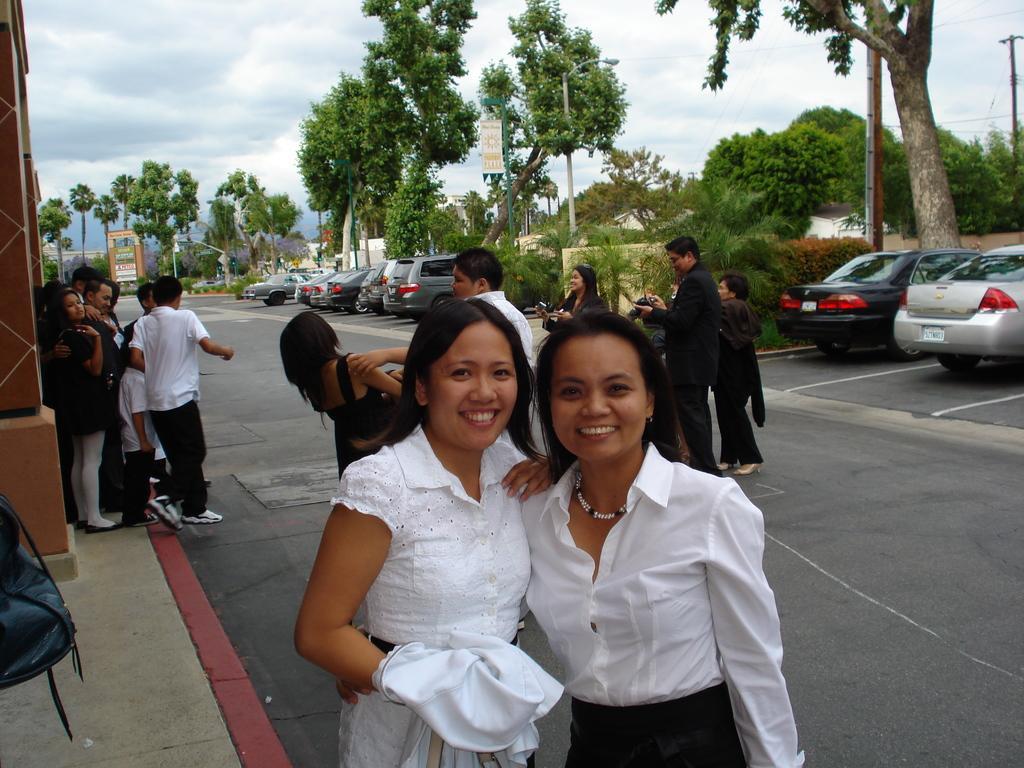Describe this image in one or two sentences. In this image we can see men and women are standing on the road and pavement. In the background, we can see cars, trees, plants, boards, poles and wires. At the top of the image, we can see the sky with clouds. On the left side of the image, we can see a pillar and a bag. 